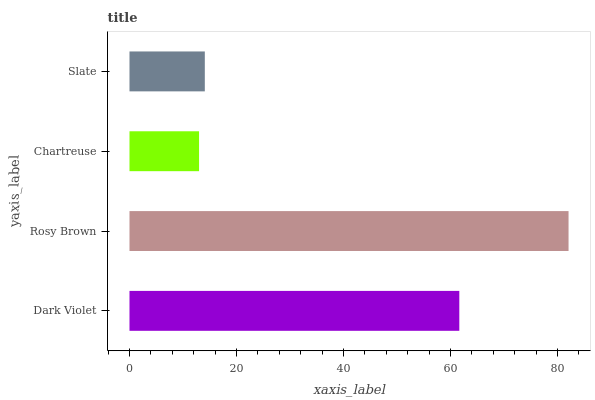Is Chartreuse the minimum?
Answer yes or no. Yes. Is Rosy Brown the maximum?
Answer yes or no. Yes. Is Rosy Brown the minimum?
Answer yes or no. No. Is Chartreuse the maximum?
Answer yes or no. No. Is Rosy Brown greater than Chartreuse?
Answer yes or no. Yes. Is Chartreuse less than Rosy Brown?
Answer yes or no. Yes. Is Chartreuse greater than Rosy Brown?
Answer yes or no. No. Is Rosy Brown less than Chartreuse?
Answer yes or no. No. Is Dark Violet the high median?
Answer yes or no. Yes. Is Slate the low median?
Answer yes or no. Yes. Is Slate the high median?
Answer yes or no. No. Is Dark Violet the low median?
Answer yes or no. No. 